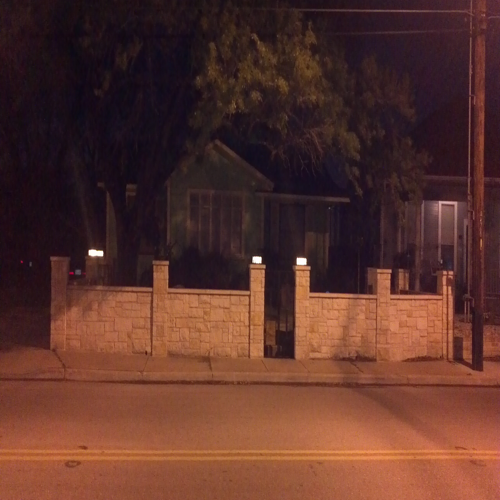Is this area well lit? The area is moderately lit with what appear to be streetlights or exterior house lights. However, there are shadows suggesting that the lighting could be improved for safety and visibility. 